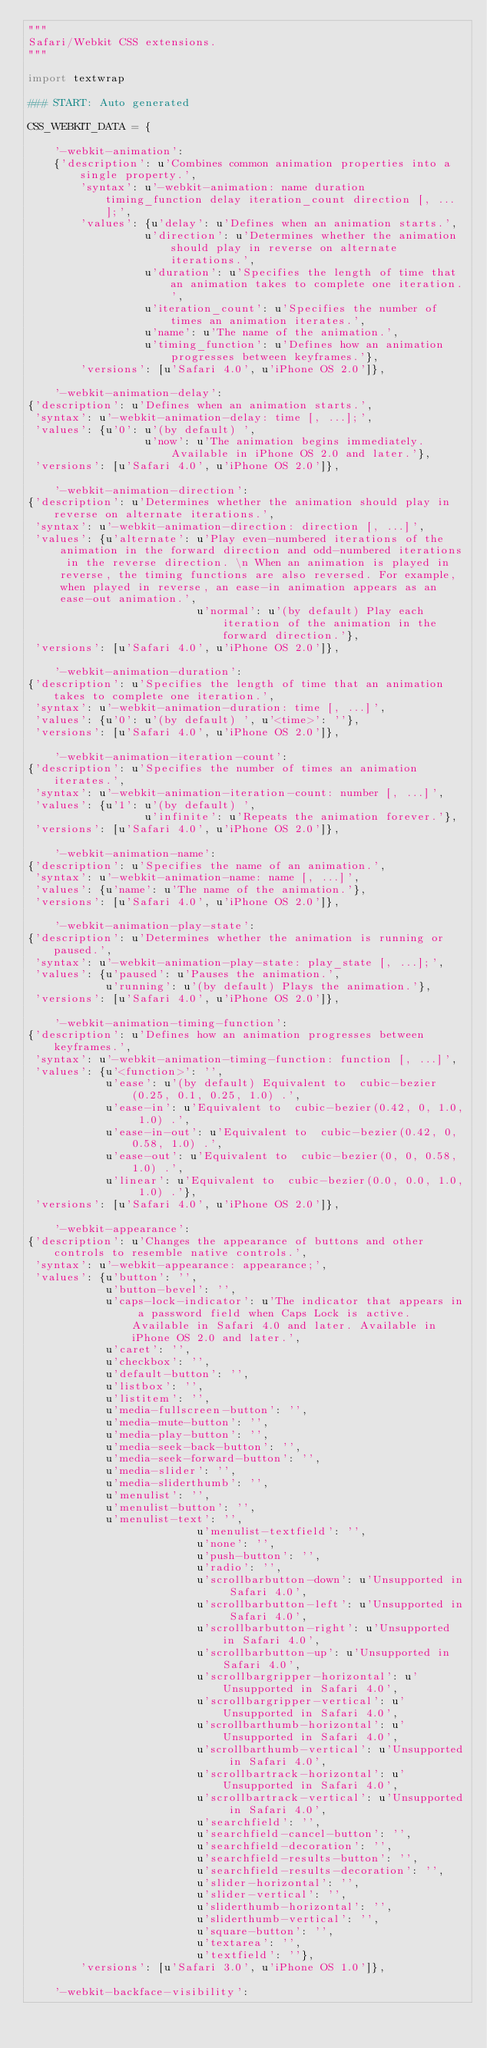Convert code to text. <code><loc_0><loc_0><loc_500><loc_500><_Python_>"""
Safari/Webkit CSS extensions.
"""

import textwrap

### START: Auto generated

CSS_WEBKIT_DATA = {

    '-webkit-animation':
    {'description': u'Combines common animation properties into a single property.',
        'syntax': u'-webkit-animation: name duration timing_function delay iteration_count direction [, ... ];',
        'values': {u'delay': u'Defines when an animation starts.',
                  u'direction': u'Determines whether the animation should play in reverse on alternate iterations.',
                  u'duration': u'Specifies the length of time that an animation takes to complete one iteration.',
                  u'iteration_count': u'Specifies the number of times an animation iterates.',
                  u'name': u'The name of the animation.',
                  u'timing_function': u'Defines how an animation progresses between keyframes.'},
        'versions': [u'Safari 4.0', u'iPhone OS 2.0']},

    '-webkit-animation-delay':
{'description': u'Defines when an animation starts.',
 'syntax': u'-webkit-animation-delay: time [, ...];',
 'values': {u'0': u'(by default) ',
                  u'now': u'The animation begins immediately. Available in iPhone OS 2.0 and later.'},
 'versions': [u'Safari 4.0', u'iPhone OS 2.0']},

    '-webkit-animation-direction':
{'description': u'Determines whether the animation should play in reverse on alternate iterations.',
 'syntax': u'-webkit-animation-direction: direction [, ...]',
 'values': {u'alternate': u'Play even-numbered iterations of the animation in the forward direction and odd-numbered iterations in the reverse direction. \n When an animation is played in reverse, the timing functions are also reversed. For example, when played in reverse, an ease-in animation appears as an ease-out animation.',
                          u'normal': u'(by default) Play each iteration of the animation in the forward direction.'},
 'versions': [u'Safari 4.0', u'iPhone OS 2.0']},

    '-webkit-animation-duration':
{'description': u'Specifies the length of time that an animation takes to complete one iteration.',
 'syntax': u'-webkit-animation-duration: time [, ...]',
 'values': {u'0': u'(by default) ', u'<time>': ''},
 'versions': [u'Safari 4.0', u'iPhone OS 2.0']},

    '-webkit-animation-iteration-count':
{'description': u'Specifies the number of times an animation iterates.',
 'syntax': u'-webkit-animation-iteration-count: number [, ...]',
 'values': {u'1': u'(by default) ',
                  u'infinite': u'Repeats the animation forever.'},
 'versions': [u'Safari 4.0', u'iPhone OS 2.0']},

    '-webkit-animation-name':
{'description': u'Specifies the name of an animation.',
 'syntax': u'-webkit-animation-name: name [, ...]',
 'values': {u'name': u'The name of the animation.'},
 'versions': [u'Safari 4.0', u'iPhone OS 2.0']},

    '-webkit-animation-play-state':
{'description': u'Determines whether the animation is running or paused.',
 'syntax': u'-webkit-animation-play-state: play_state [, ...];',
 'values': {u'paused': u'Pauses the animation.',
            u'running': u'(by default) Plays the animation.'},
 'versions': [u'Safari 4.0', u'iPhone OS 2.0']},

    '-webkit-animation-timing-function':
{'description': u'Defines how an animation progresses between keyframes.',
 'syntax': u'-webkit-animation-timing-function: function [, ...]',
 'values': {u'<function>': '',
            u'ease': u'(by default) Equivalent to  cubic-bezier(0.25, 0.1, 0.25, 1.0) .',
            u'ease-in': u'Equivalent to  cubic-bezier(0.42, 0, 1.0, 1.0) .',
            u'ease-in-out': u'Equivalent to  cubic-bezier(0.42, 0, 0.58, 1.0) .',
            u'ease-out': u'Equivalent to  cubic-bezier(0, 0, 0.58, 1.0) .',
            u'linear': u'Equivalent to  cubic-bezier(0.0, 0.0, 1.0, 1.0) .'},
 'versions': [u'Safari 4.0', u'iPhone OS 2.0']},

    '-webkit-appearance':
{'description': u'Changes the appearance of buttons and other controls to resemble native controls.',
 'syntax': u'-webkit-appearance: appearance;',
 'values': {u'button': '',
            u'button-bevel': '',
            u'caps-lock-indicator': u'The indicator that appears in a password field when Caps Lock is active. Available in Safari 4.0 and later. Available in iPhone OS 2.0 and later.',
            u'caret': '',
            u'checkbox': '',
            u'default-button': '',
            u'listbox': '',
            u'listitem': '',
            u'media-fullscreen-button': '',
            u'media-mute-button': '',
            u'media-play-button': '',
            u'media-seek-back-button': '',
            u'media-seek-forward-button': '',
            u'media-slider': '',
            u'media-sliderthumb': '',
            u'menulist': '',
            u'menulist-button': '',
            u'menulist-text': '',
                          u'menulist-textfield': '',
                          u'none': '',
                          u'push-button': '',
                          u'radio': '',
                          u'scrollbarbutton-down': u'Unsupported in Safari 4.0',
                          u'scrollbarbutton-left': u'Unsupported in Safari 4.0',
                          u'scrollbarbutton-right': u'Unsupported in Safari 4.0',
                          u'scrollbarbutton-up': u'Unsupported in Safari 4.0',
                          u'scrollbargripper-horizontal': u'Unsupported in Safari 4.0',
                          u'scrollbargripper-vertical': u'Unsupported in Safari 4.0',
                          u'scrollbarthumb-horizontal': u'Unsupported in Safari 4.0',
                          u'scrollbarthumb-vertical': u'Unsupported in Safari 4.0',
                          u'scrollbartrack-horizontal': u'Unsupported in Safari 4.0',
                          u'scrollbartrack-vertical': u'Unsupported in Safari 4.0',
                          u'searchfield': '',
                          u'searchfield-cancel-button': '',
                          u'searchfield-decoration': '',
                          u'searchfield-results-button': '',
                          u'searchfield-results-decoration': '',
                          u'slider-horizontal': '',
                          u'slider-vertical': '',
                          u'sliderthumb-horizontal': '',
                          u'sliderthumb-vertical': '',
                          u'square-button': '',
                          u'textarea': '',
                          u'textfield': ''},
        'versions': [u'Safari 3.0', u'iPhone OS 1.0']},

    '-webkit-backface-visibility':</code> 